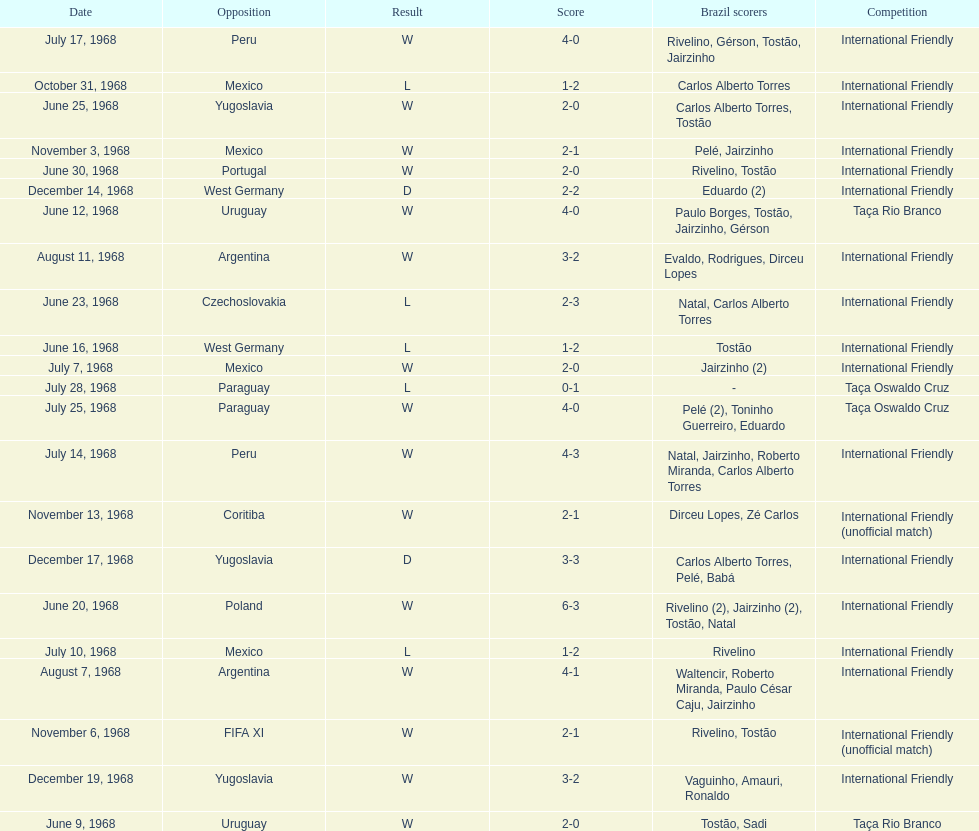In which year was the highest scoring game recorded? 1968. Give me the full table as a dictionary. {'header': ['Date', 'Opposition', 'Result', 'Score', 'Brazil scorers', 'Competition'], 'rows': [['July 17, 1968', 'Peru', 'W', '4-0', 'Rivelino, Gérson, Tostão, Jairzinho', 'International Friendly'], ['October 31, 1968', 'Mexico', 'L', '1-2', 'Carlos Alberto Torres', 'International Friendly'], ['June 25, 1968', 'Yugoslavia', 'W', '2-0', 'Carlos Alberto Torres, Tostão', 'International Friendly'], ['November 3, 1968', 'Mexico', 'W', '2-1', 'Pelé, Jairzinho', 'International Friendly'], ['June 30, 1968', 'Portugal', 'W', '2-0', 'Rivelino, Tostão', 'International Friendly'], ['December 14, 1968', 'West Germany', 'D', '2-2', 'Eduardo (2)', 'International Friendly'], ['June 12, 1968', 'Uruguay', 'W', '4-0', 'Paulo Borges, Tostão, Jairzinho, Gérson', 'Taça Rio Branco'], ['August 11, 1968', 'Argentina', 'W', '3-2', 'Evaldo, Rodrigues, Dirceu Lopes', 'International Friendly'], ['June 23, 1968', 'Czechoslovakia', 'L', '2-3', 'Natal, Carlos Alberto Torres', 'International Friendly'], ['June 16, 1968', 'West Germany', 'L', '1-2', 'Tostão', 'International Friendly'], ['July 7, 1968', 'Mexico', 'W', '2-0', 'Jairzinho (2)', 'International Friendly'], ['July 28, 1968', 'Paraguay', 'L', '0-1', '-', 'Taça Oswaldo Cruz'], ['July 25, 1968', 'Paraguay', 'W', '4-0', 'Pelé (2), Toninho Guerreiro, Eduardo', 'Taça Oswaldo Cruz'], ['July 14, 1968', 'Peru', 'W', '4-3', 'Natal, Jairzinho, Roberto Miranda, Carlos Alberto Torres', 'International Friendly'], ['November 13, 1968', 'Coritiba', 'W', '2-1', 'Dirceu Lopes, Zé Carlos', 'International Friendly (unofficial match)'], ['December 17, 1968', 'Yugoslavia', 'D', '3-3', 'Carlos Alberto Torres, Pelé, Babá', 'International Friendly'], ['June 20, 1968', 'Poland', 'W', '6-3', 'Rivelino (2), Jairzinho (2), Tostão, Natal', 'International Friendly'], ['July 10, 1968', 'Mexico', 'L', '1-2', 'Rivelino', 'International Friendly'], ['August 7, 1968', 'Argentina', 'W', '4-1', 'Waltencir, Roberto Miranda, Paulo César Caju, Jairzinho', 'International Friendly'], ['November 6, 1968', 'FIFA XI', 'W', '2-1', 'Rivelino, Tostão', 'International Friendly (unofficial match)'], ['December 19, 1968', 'Yugoslavia', 'W', '3-2', 'Vaguinho, Amauri, Ronaldo', 'International Friendly'], ['June 9, 1968', 'Uruguay', 'W', '2-0', 'Tostão, Sadi', 'Taça Rio Branco']]} 